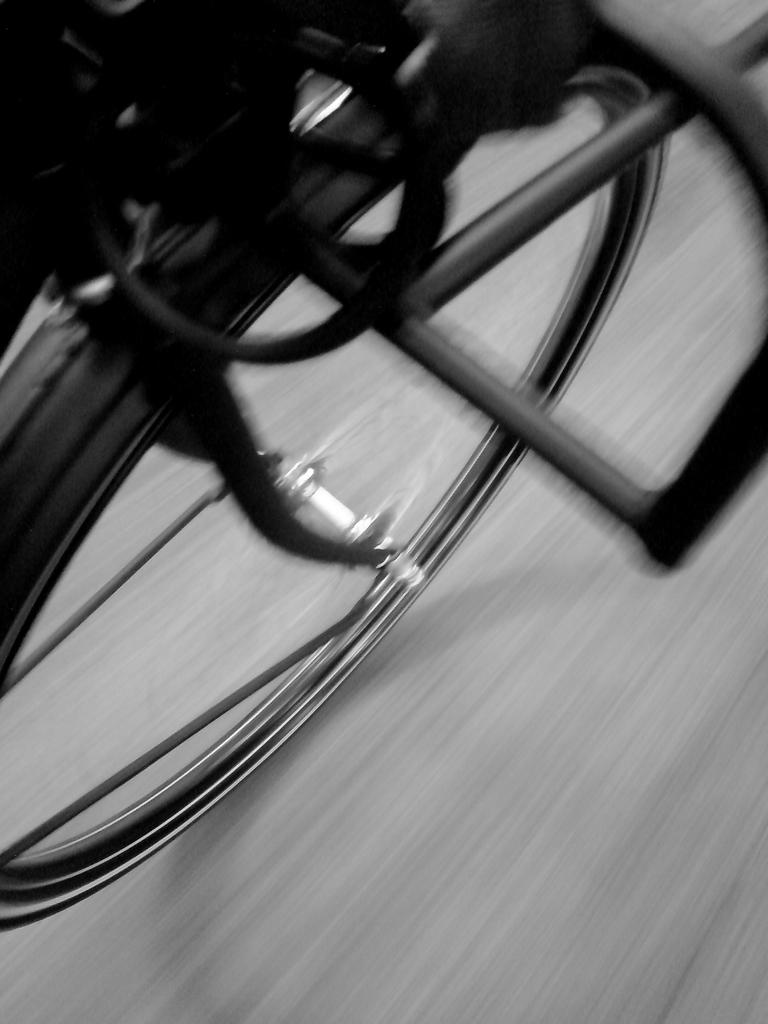What is the color scheme of the image? The image is black and white. What is the main subject in the center of the image? There is a wheel in the center of the image. Where is the wheel located? The wheel is on the road. What can be seen on the wheel? There are objects on the wheel. How does the wheel grip the road during the rainstorm in the image? There is no rainstorm present in the image, and the wheel's grip on the road cannot be determined from the image alone. 